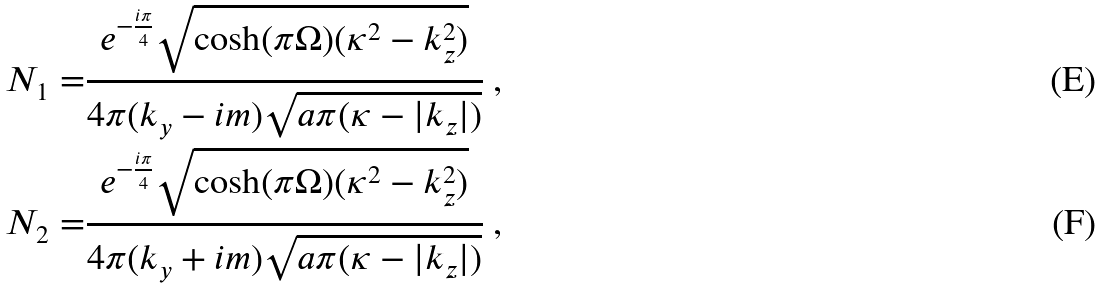Convert formula to latex. <formula><loc_0><loc_0><loc_500><loc_500>N _ { 1 } = & \frac { e ^ { - \frac { i \pi } { 4 } } \sqrt { \cosh ( \pi { \Omega } ) ( \kappa ^ { 2 } - k _ { z } ^ { 2 } ) } } { 4 \pi ( k _ { y } - i m ) \sqrt { a \pi ( \kappa - | k _ { z } | ) } } \ , \\ N _ { 2 } = & \frac { e ^ { - \frac { i \pi } { 4 } } \sqrt { \cosh ( \pi { \Omega } ) ( \kappa ^ { 2 } - k _ { z } ^ { 2 } ) } } { 4 \pi ( k _ { y } + i m ) \sqrt { a \pi ( \kappa - | k _ { z } | ) } } \ ,</formula> 